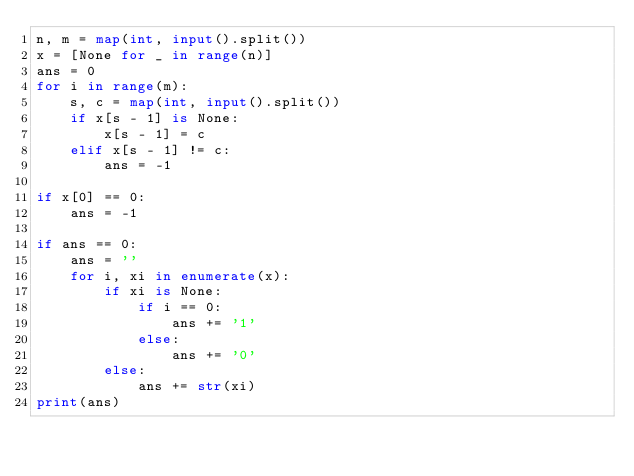Convert code to text. <code><loc_0><loc_0><loc_500><loc_500><_Python_>n, m = map(int, input().split())
x = [None for _ in range(n)]
ans = 0
for i in range(m):
    s, c = map(int, input().split())
    if x[s - 1] is None:
        x[s - 1] = c
    elif x[s - 1] != c:
        ans = -1

if x[0] == 0:
    ans = -1

if ans == 0:
    ans = ''
    for i, xi in enumerate(x):
        if xi is None:
            if i == 0:
                ans += '1'
            else:
                ans += '0'
        else:
            ans += str(xi)
print(ans)
</code> 